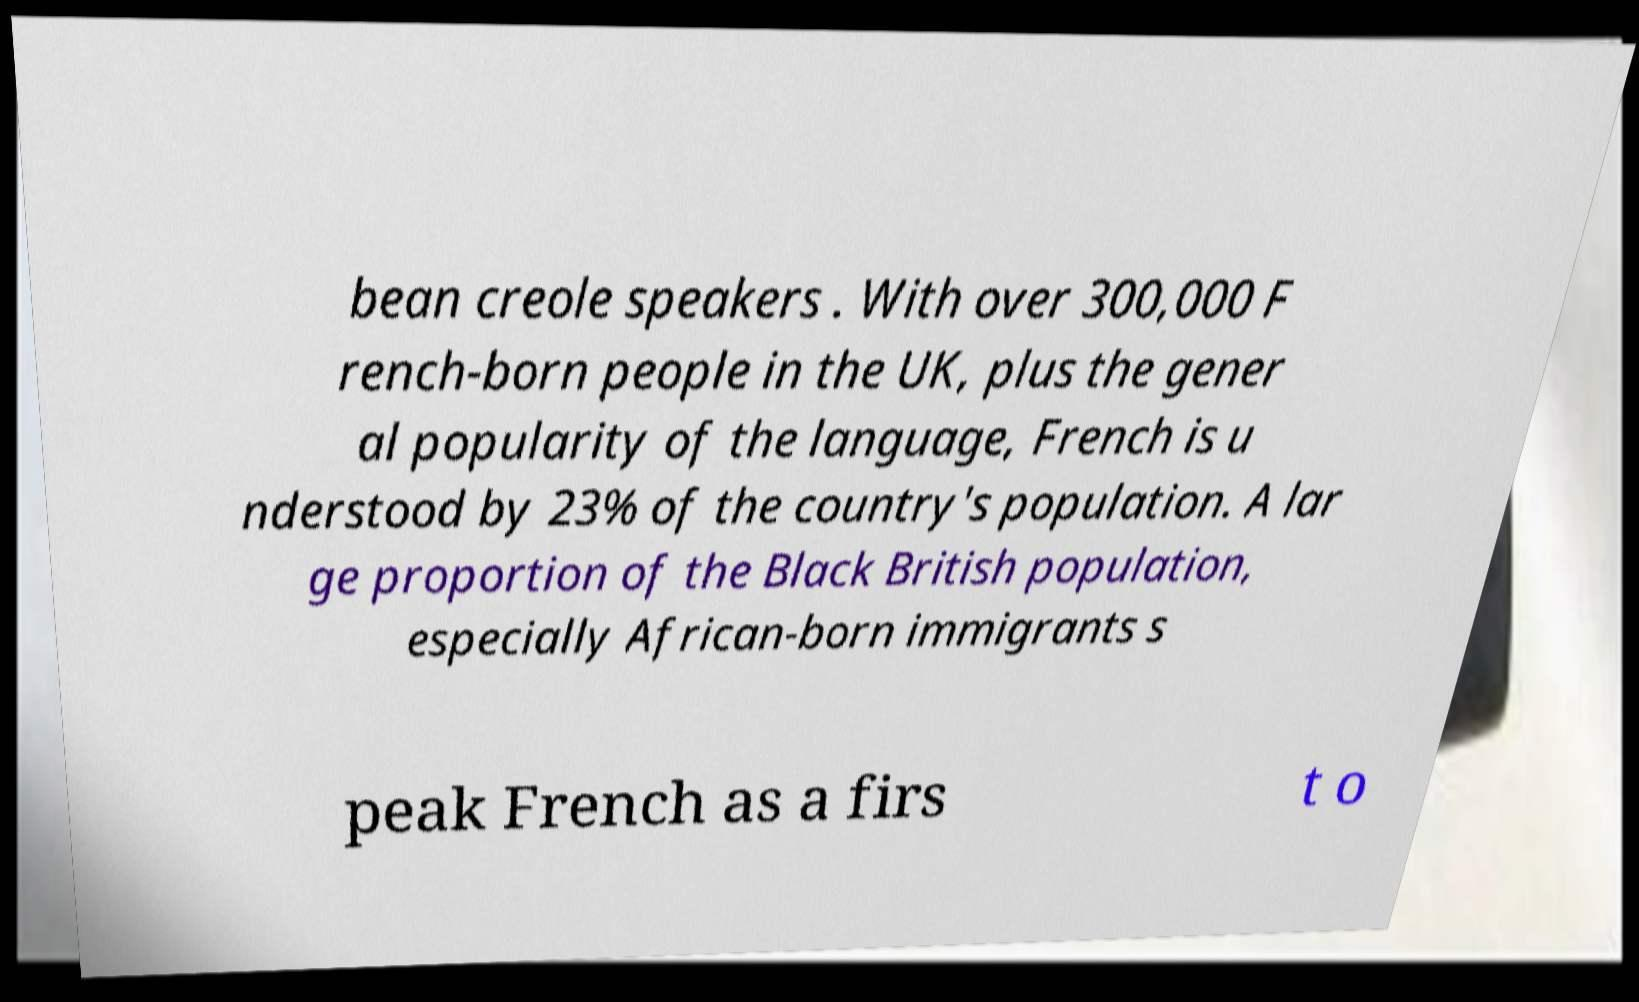Please read and relay the text visible in this image. What does it say? bean creole speakers . With over 300,000 F rench-born people in the UK, plus the gener al popularity of the language, French is u nderstood by 23% of the country's population. A lar ge proportion of the Black British population, especially African-born immigrants s peak French as a firs t o 